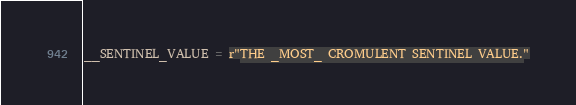<code> <loc_0><loc_0><loc_500><loc_500><_Python_>
__SENTINEL_VALUE = r"THE _MOST_ CROMULENT SENTINEL VALUE."</code> 